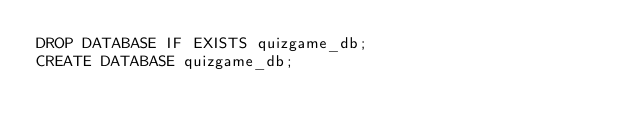<code> <loc_0><loc_0><loc_500><loc_500><_SQL_>DROP DATABASE IF EXISTS quizgame_db;
CREATE DATABASE quizgame_db;</code> 